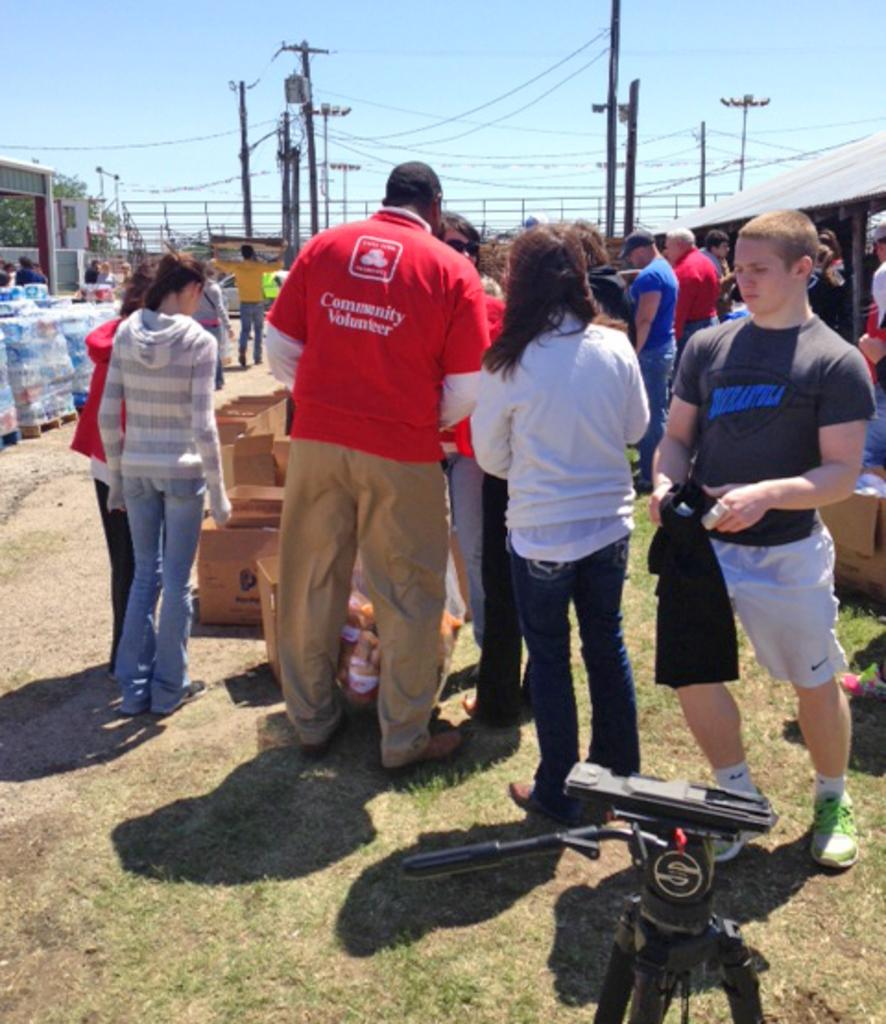What is the main subject of the image? The main subject of the image is a group of persons standing on the grass in the center of the image. What equipment can be seen at the bottom of the image? There is a camera stand at the bottom of the image. What can be seen in the background of the image? In the background of the image, there are poles, a tree, and the sky. What is the average income of the family in the image? There is no family present in the image, and therefore no income can be determined. How does the sand affect the stability of the poles in the background? There is no sand present in the image, so this question cannot be answered. 